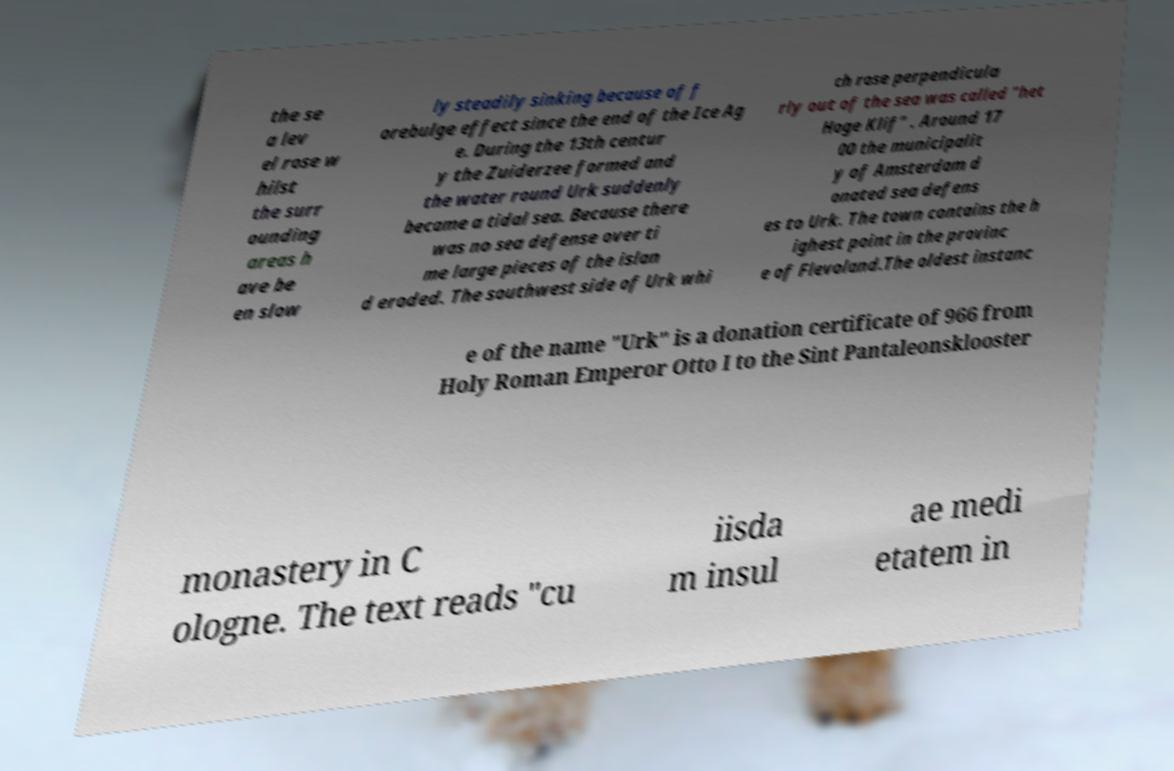Can you accurately transcribe the text from the provided image for me? the se a lev el rose w hilst the surr ounding areas h ave be en slow ly steadily sinking because of f orebulge effect since the end of the Ice Ag e. During the 13th centur y the Zuiderzee formed and the water round Urk suddenly became a tidal sea. Because there was no sea defense over ti me large pieces of the islan d eroded. The southwest side of Urk whi ch rose perpendicula rly out of the sea was called "het Hoge Klif" . Around 17 00 the municipalit y of Amsterdam d onated sea defens es to Urk. The town contains the h ighest point in the provinc e of Flevoland.The oldest instanc e of the name "Urk" is a donation certificate of 966 from Holy Roman Emperor Otto I to the Sint Pantaleonsklooster monastery in C ologne. The text reads "cu iisda m insul ae medi etatem in 